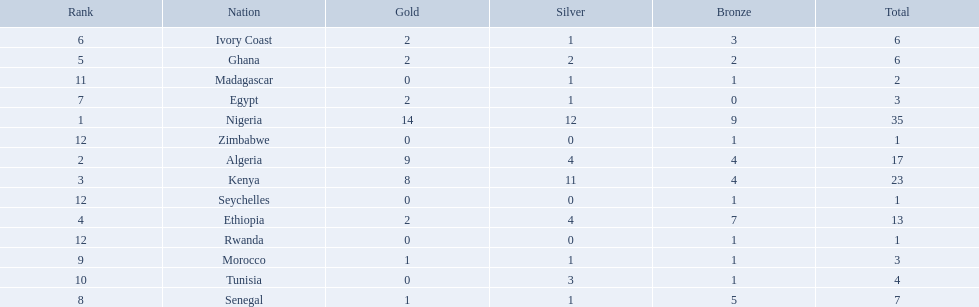Which nations competed in the 1989 african championships in athletics? Nigeria, Algeria, Kenya, Ethiopia, Ghana, Ivory Coast, Egypt, Senegal, Morocco, Tunisia, Madagascar, Rwanda, Zimbabwe, Seychelles. Of these nations, which earned 0 bronze medals? Egypt. 